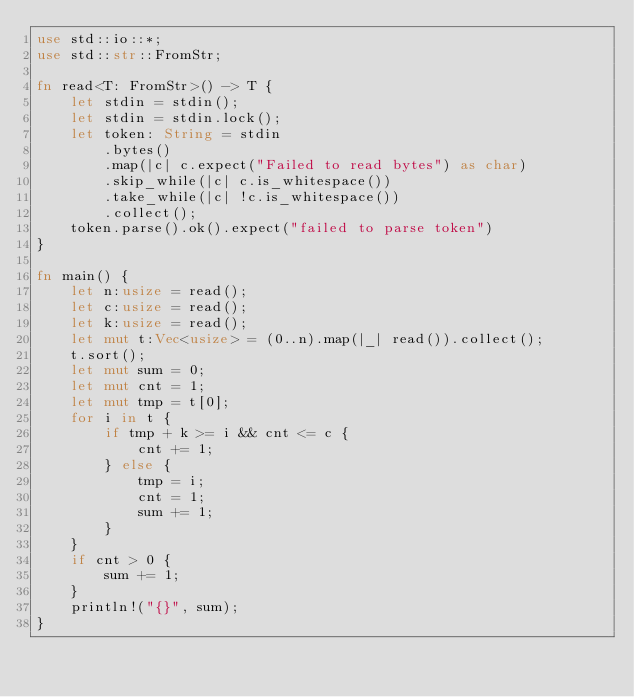<code> <loc_0><loc_0><loc_500><loc_500><_Rust_>use std::io::*;
use std::str::FromStr;

fn read<T: FromStr>() -> T {
    let stdin = stdin();
    let stdin = stdin.lock();
    let token: String = stdin
        .bytes()
        .map(|c| c.expect("Failed to read bytes") as char)
        .skip_while(|c| c.is_whitespace())
        .take_while(|c| !c.is_whitespace())
        .collect();
    token.parse().ok().expect("failed to parse token")
}

fn main() {
    let n:usize = read();
    let c:usize = read();
    let k:usize = read();
    let mut t:Vec<usize> = (0..n).map(|_| read()).collect();
    t.sort();
    let mut sum = 0;
    let mut cnt = 1;
    let mut tmp = t[0];
    for i in t {
        if tmp + k >= i && cnt <= c {
            cnt += 1;
        } else {
            tmp = i;
            cnt = 1;
            sum += 1;
        }
    }
    if cnt > 0 {
        sum += 1;
    }
    println!("{}", sum);
}
</code> 